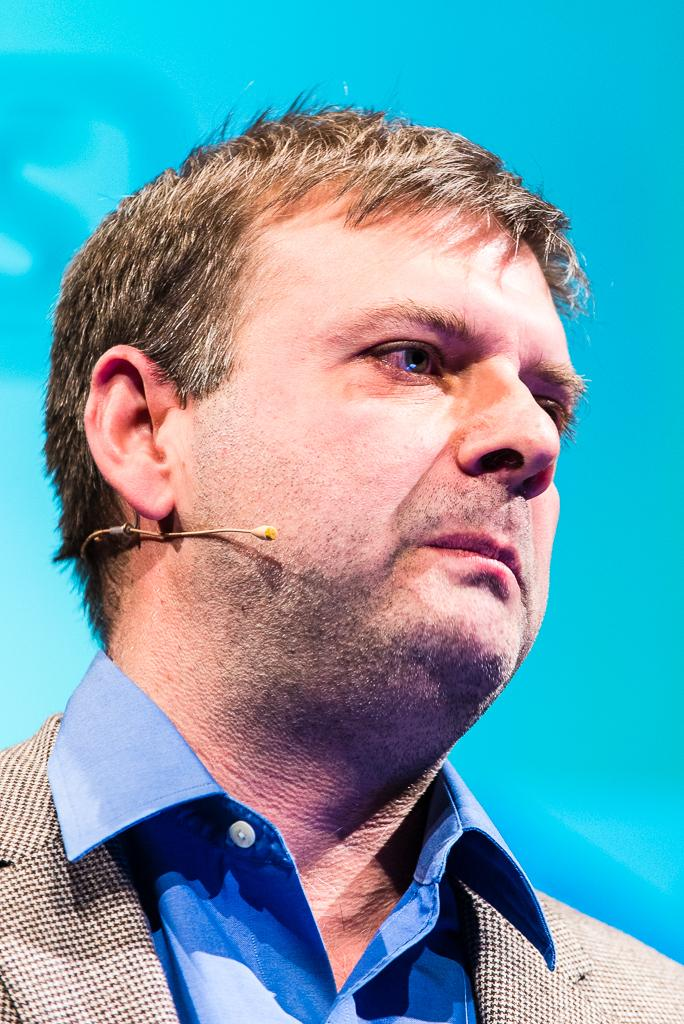What is the main subject of the image? The main subject of the image is a man. Can you describe the man's position in the image? The man is in the center of the image. What emotion does the man express towards the person he hates in the image? There is no indication in the image that the man hates anyone or expresses any specific emotion. 